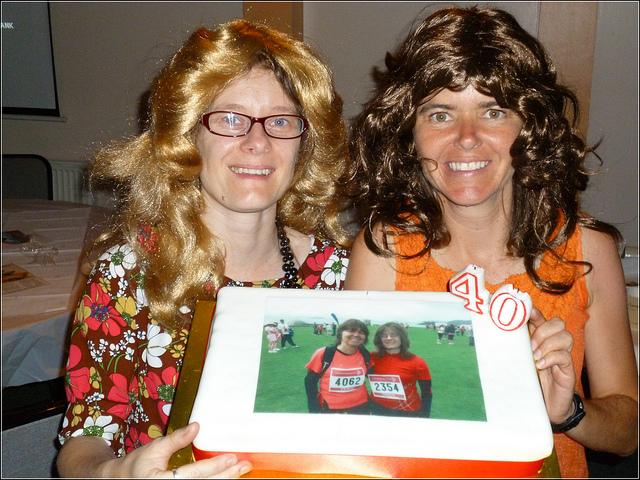Do identical twins have 100% the same DNA? yes 